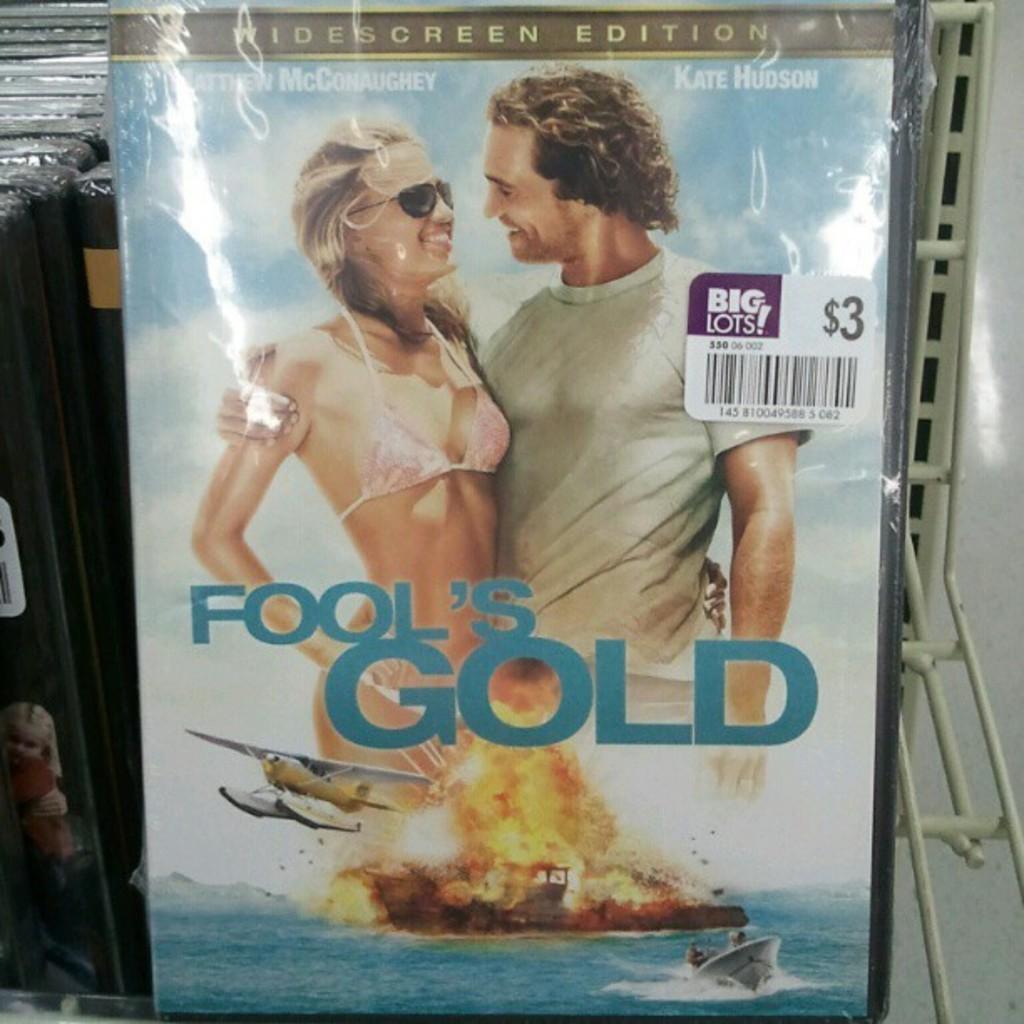What's the dollar value of fool's gold?
Your answer should be very brief. $3. Who is the actor in the poster?
Offer a very short reply. Matthew mcconaughey. 